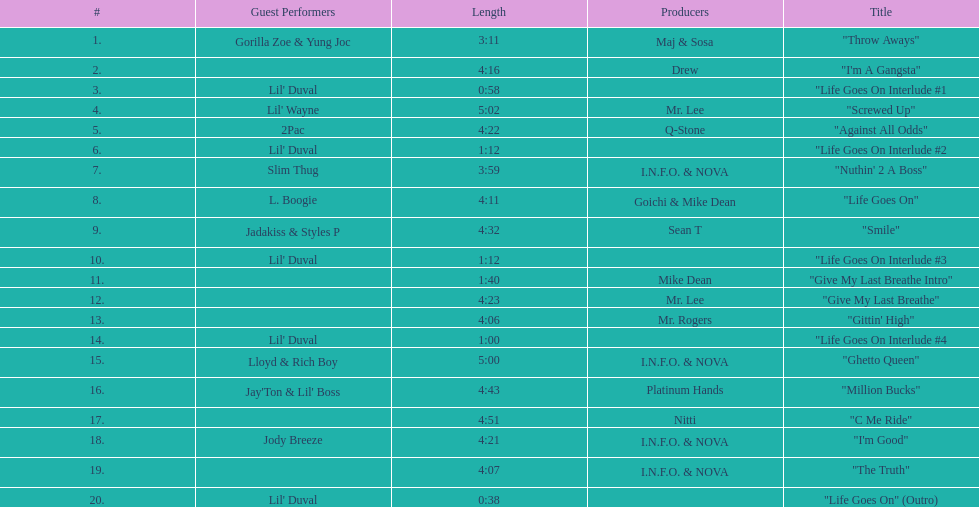What is the longest track on the album? "Screwed Up". 